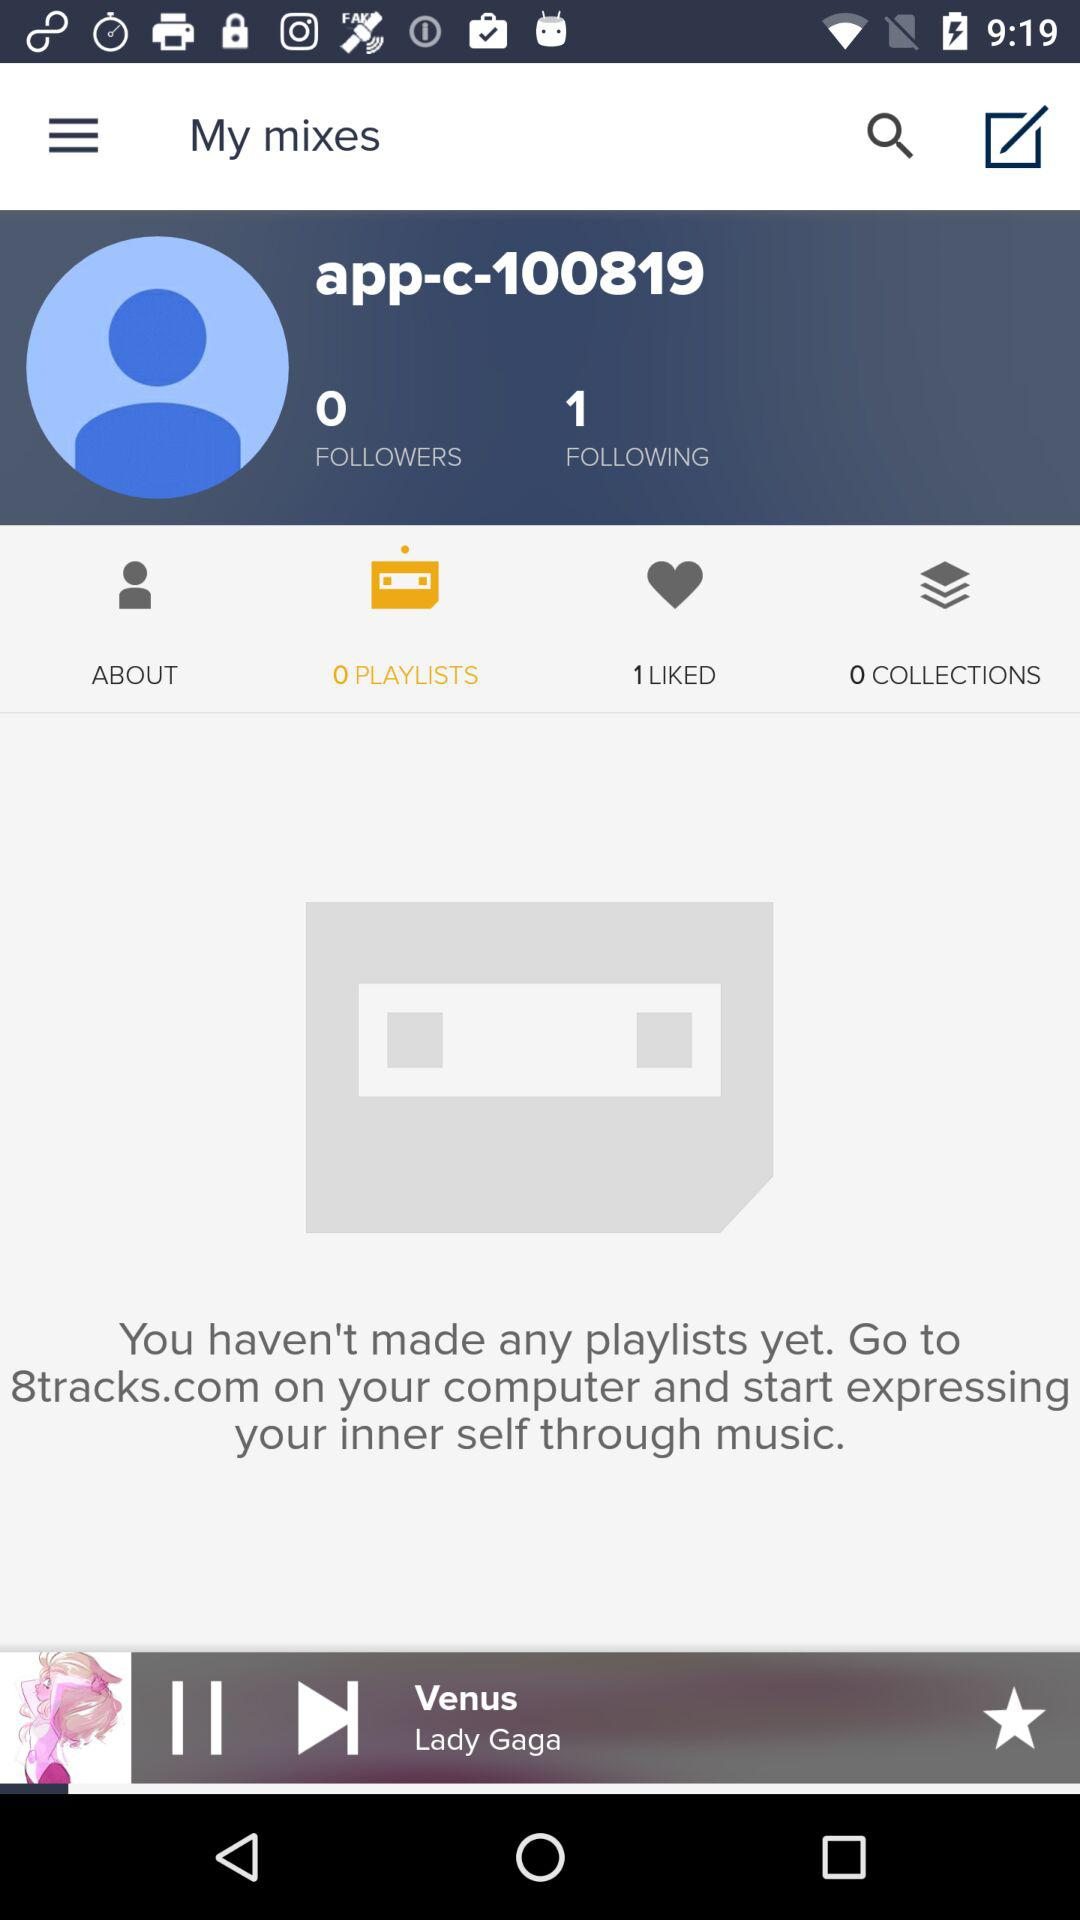Which tab has been selected? The tab that has been selected is "O PLAYLISTS". 